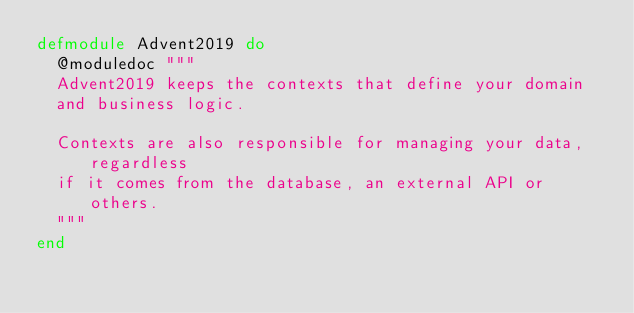Convert code to text. <code><loc_0><loc_0><loc_500><loc_500><_Elixir_>defmodule Advent2019 do
  @moduledoc """
  Advent2019 keeps the contexts that define your domain
  and business logic.

  Contexts are also responsible for managing your data, regardless
  if it comes from the database, an external API or others.
  """
end
</code> 